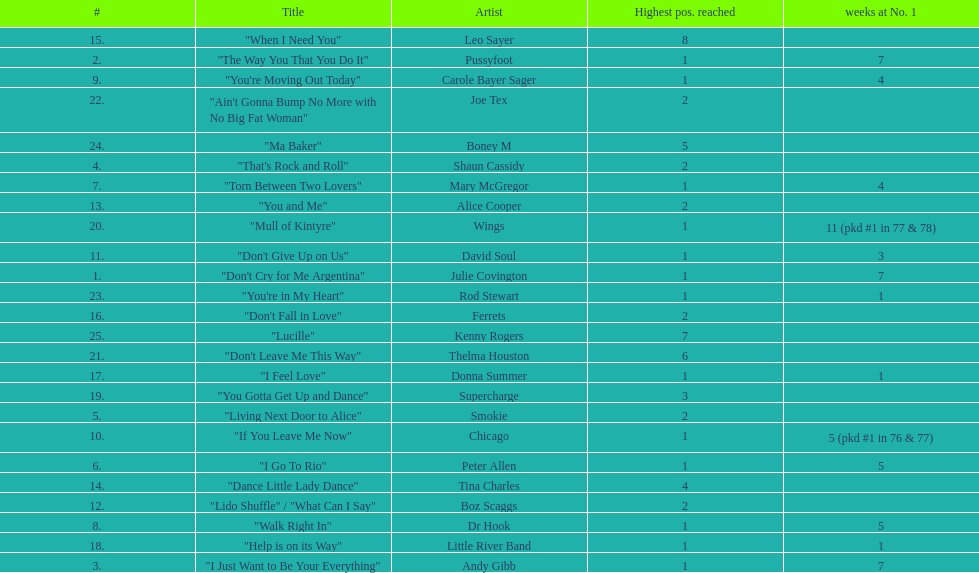Can you give me this table as a dict? {'header': ['#', 'Title', 'Artist', 'Highest pos. reached', 'weeks at No. 1'], 'rows': [['15.', '"When I Need You"', 'Leo Sayer', '8', ''], ['2.', '"The Way You That You Do It"', 'Pussyfoot', '1', '7'], ['9.', '"You\'re Moving Out Today"', 'Carole Bayer Sager', '1', '4'], ['22.', '"Ain\'t Gonna Bump No More with No Big Fat Woman"', 'Joe Tex', '2', ''], ['24.', '"Ma Baker"', 'Boney M', '5', ''], ['4.', '"That\'s Rock and Roll"', 'Shaun Cassidy', '2', ''], ['7.', '"Torn Between Two Lovers"', 'Mary McGregor', '1', '4'], ['13.', '"You and Me"', 'Alice Cooper', '2', ''], ['20.', '"Mull of Kintyre"', 'Wings', '1', '11 (pkd #1 in 77 & 78)'], ['11.', '"Don\'t Give Up on Us"', 'David Soul', '1', '3'], ['1.', '"Don\'t Cry for Me Argentina"', 'Julie Covington', '1', '7'], ['23.', '"You\'re in My Heart"', 'Rod Stewart', '1', '1'], ['16.', '"Don\'t Fall in Love"', 'Ferrets', '2', ''], ['25.', '"Lucille"', 'Kenny Rogers', '7', ''], ['21.', '"Don\'t Leave Me This Way"', 'Thelma Houston', '6', ''], ['17.', '"I Feel Love"', 'Donna Summer', '1', '1'], ['19.', '"You Gotta Get Up and Dance"', 'Supercharge', '3', ''], ['5.', '"Living Next Door to Alice"', 'Smokie', '2', ''], ['10.', '"If You Leave Me Now"', 'Chicago', '1', '5 (pkd #1 in 76 & 77)'], ['6.', '"I Go To Rio"', 'Peter Allen', '1', '5'], ['14.', '"Dance Little Lady Dance"', 'Tina Charles', '4', ''], ['12.', '"Lido Shuffle" / "What Can I Say"', 'Boz Scaggs', '2', ''], ['8.', '"Walk Right In"', 'Dr Hook', '1', '5'], ['18.', '"Help is on its Way"', 'Little River Band', '1', '1'], ['3.', '"I Just Want to Be Your Everything"', 'Andy Gibb', '1', '7']]} Who had the most weeks at number one, according to the table? Wings. 